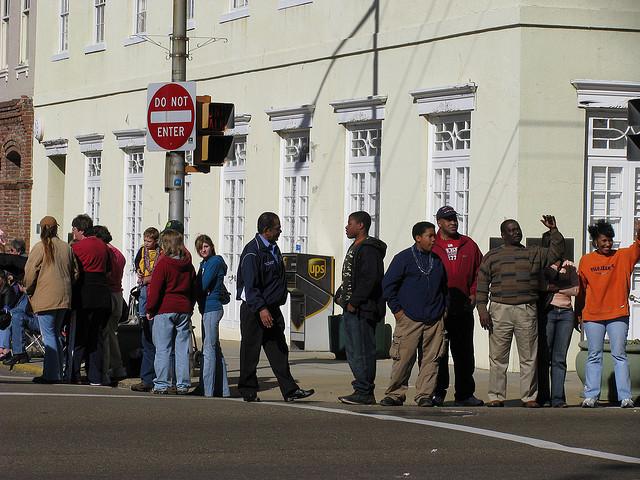Is there wheels in this picture?
Keep it brief. No. What should one not do according to the sign?
Answer briefly. Enter. What name does the building have on the front?
Give a very brief answer. None. Why are people gathered beside the street?
Be succinct. Waiting to cross. Is this a street corner?
Keep it brief. Yes. Do these people know each other?
Answer briefly. No. Could this be a European train station?
Give a very brief answer. No. What color is the sign?
Write a very short answer. Red and white. How many people dressed in red?
Quick response, please. 3. Is the man in orange mad or happy?
Keep it brief. Happy. 